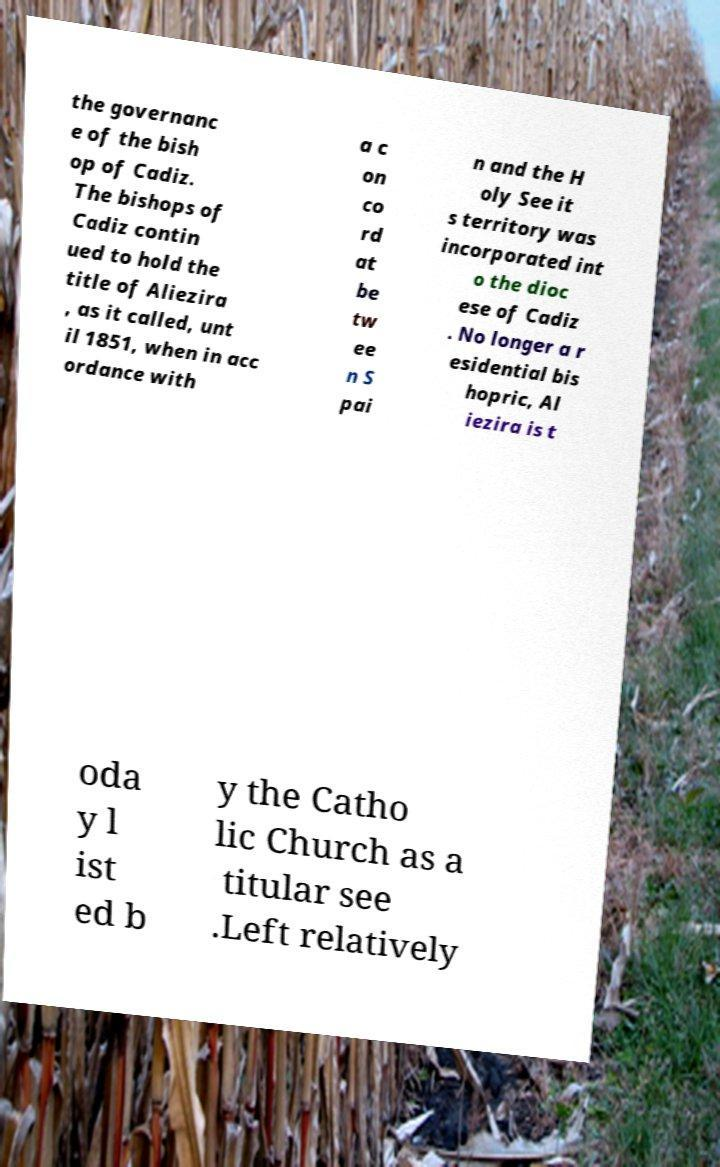For documentation purposes, I need the text within this image transcribed. Could you provide that? the governanc e of the bish op of Cadiz. The bishops of Cadiz contin ued to hold the title of Aliezira , as it called, unt il 1851, when in acc ordance with a c on co rd at be tw ee n S pai n and the H oly See it s territory was incorporated int o the dioc ese of Cadiz . No longer a r esidential bis hopric, Al iezira is t oda y l ist ed b y the Catho lic Church as a titular see .Left relatively 